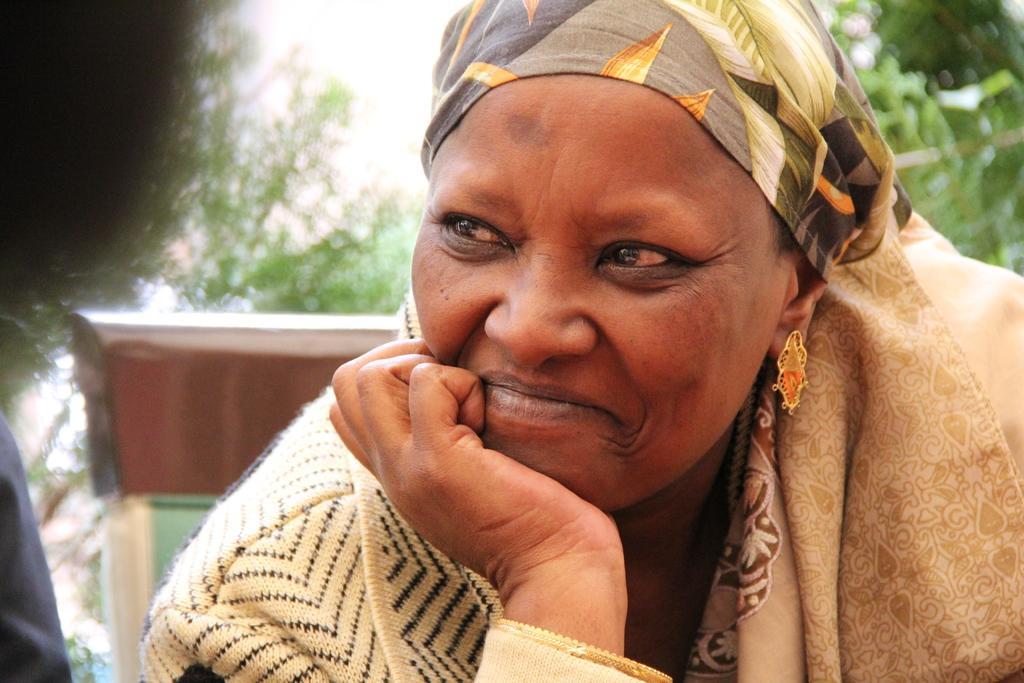How would you summarize this image in a sentence or two? This picture shows a woman seated on the chair with a smile on her face and a cloth on her head and we see trees and another woman seated on the side. 